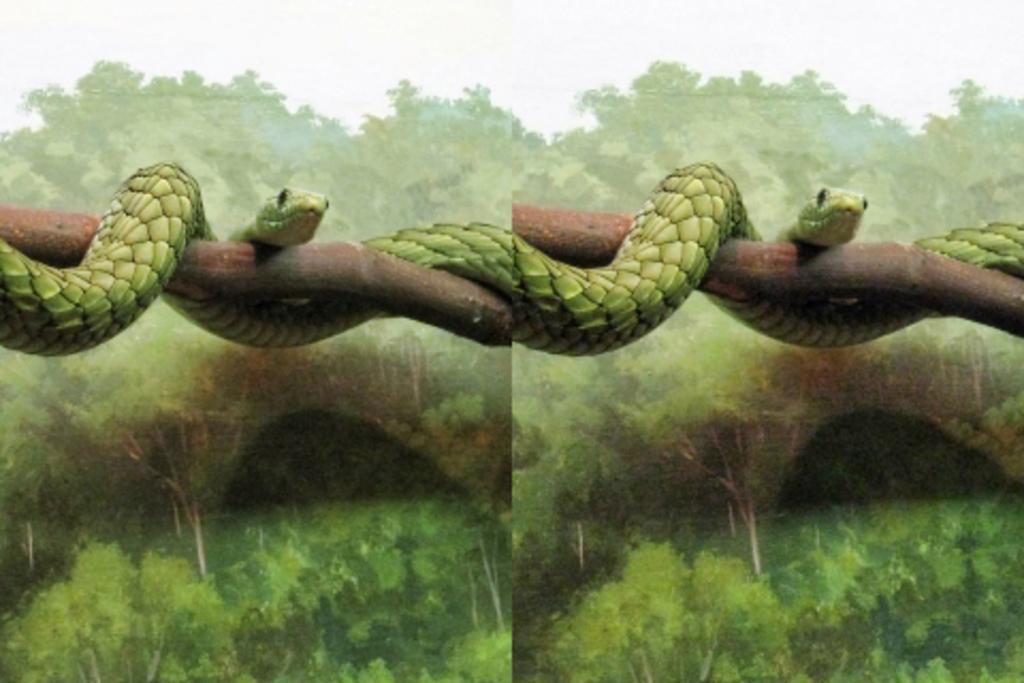How would you summarize this image in a sentence or two? This image is collage of two images. There is a snake on the branch. 